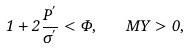Convert formula to latex. <formula><loc_0><loc_0><loc_500><loc_500>1 + 2 \frac { P ^ { ^ { \prime } } } { \sigma ^ { ^ { \prime } } } < \Phi , \quad M \Upsilon > 0 ,</formula> 